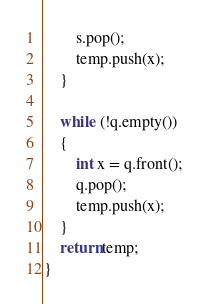<code> <loc_0><loc_0><loc_500><loc_500><_C++_>        s.pop();
        temp.push(x);
    }

    while (!q.empty())
    {
        int x = q.front();
        q.pop();
        temp.push(x);
    }
    return temp;
}</code> 